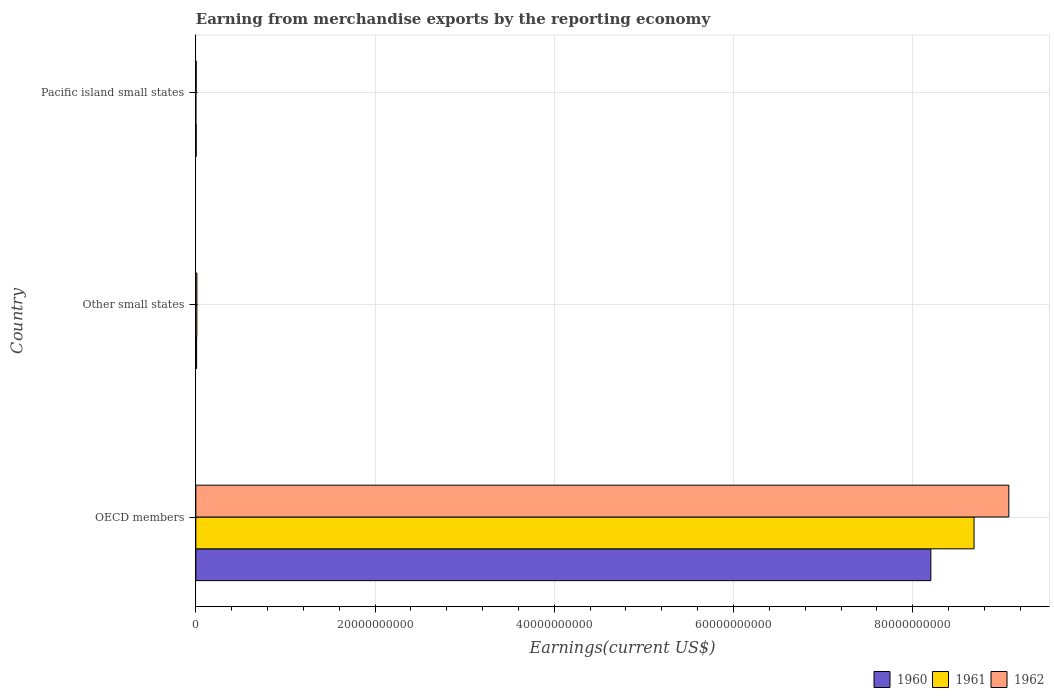How many groups of bars are there?
Keep it short and to the point. 3. Are the number of bars on each tick of the Y-axis equal?
Keep it short and to the point. Yes. How many bars are there on the 3rd tick from the top?
Your answer should be compact. 3. How many bars are there on the 1st tick from the bottom?
Ensure brevity in your answer.  3. What is the amount earned from merchandise exports in 1961 in Pacific island small states?
Your answer should be compact. 2.00e+05. Across all countries, what is the maximum amount earned from merchandise exports in 1960?
Offer a very short reply. 8.20e+1. In which country was the amount earned from merchandise exports in 1962 minimum?
Keep it short and to the point. Pacific island small states. What is the total amount earned from merchandise exports in 1961 in the graph?
Your answer should be very brief. 8.70e+1. What is the difference between the amount earned from merchandise exports in 1960 in OECD members and that in Other small states?
Ensure brevity in your answer.  8.19e+1. What is the difference between the amount earned from merchandise exports in 1960 in Pacific island small states and the amount earned from merchandise exports in 1961 in Other small states?
Offer a very short reply. -7.61e+07. What is the average amount earned from merchandise exports in 1962 per country?
Your answer should be very brief. 3.03e+1. What is the difference between the amount earned from merchandise exports in 1961 and amount earned from merchandise exports in 1960 in Pacific island small states?
Your response must be concise. -3.93e+07. In how many countries, is the amount earned from merchandise exports in 1960 greater than 72000000000 US$?
Offer a terse response. 1. What is the ratio of the amount earned from merchandise exports in 1962 in Other small states to that in Pacific island small states?
Provide a succinct answer. 2.99. What is the difference between the highest and the second highest amount earned from merchandise exports in 1960?
Provide a succinct answer. 8.19e+1. What is the difference between the highest and the lowest amount earned from merchandise exports in 1962?
Provide a short and direct response. 9.07e+1. Is it the case that in every country, the sum of the amount earned from merchandise exports in 1960 and amount earned from merchandise exports in 1961 is greater than the amount earned from merchandise exports in 1962?
Your answer should be very brief. No. How many bars are there?
Your response must be concise. 9. What is the difference between two consecutive major ticks on the X-axis?
Give a very brief answer. 2.00e+1. Where does the legend appear in the graph?
Your answer should be compact. Bottom right. What is the title of the graph?
Offer a terse response. Earning from merchandise exports by the reporting economy. What is the label or title of the X-axis?
Ensure brevity in your answer.  Earnings(current US$). What is the Earnings(current US$) in 1960 in OECD members?
Give a very brief answer. 8.20e+1. What is the Earnings(current US$) of 1961 in OECD members?
Keep it short and to the point. 8.68e+1. What is the Earnings(current US$) in 1962 in OECD members?
Provide a short and direct response. 9.07e+1. What is the Earnings(current US$) of 1960 in Other small states?
Provide a short and direct response. 8.66e+07. What is the Earnings(current US$) of 1961 in Other small states?
Ensure brevity in your answer.  1.16e+08. What is the Earnings(current US$) of 1962 in Other small states?
Your answer should be compact. 1.19e+08. What is the Earnings(current US$) of 1960 in Pacific island small states?
Give a very brief answer. 3.95e+07. What is the Earnings(current US$) in 1961 in Pacific island small states?
Provide a succinct answer. 2.00e+05. What is the Earnings(current US$) of 1962 in Pacific island small states?
Offer a terse response. 3.97e+07. Across all countries, what is the maximum Earnings(current US$) in 1960?
Offer a terse response. 8.20e+1. Across all countries, what is the maximum Earnings(current US$) in 1961?
Your answer should be very brief. 8.68e+1. Across all countries, what is the maximum Earnings(current US$) in 1962?
Offer a terse response. 9.07e+1. Across all countries, what is the minimum Earnings(current US$) of 1960?
Offer a terse response. 3.95e+07. Across all countries, what is the minimum Earnings(current US$) of 1962?
Provide a short and direct response. 3.97e+07. What is the total Earnings(current US$) in 1960 in the graph?
Provide a succinct answer. 8.22e+1. What is the total Earnings(current US$) in 1961 in the graph?
Your response must be concise. 8.70e+1. What is the total Earnings(current US$) of 1962 in the graph?
Offer a terse response. 9.09e+1. What is the difference between the Earnings(current US$) of 1960 in OECD members and that in Other small states?
Your response must be concise. 8.19e+1. What is the difference between the Earnings(current US$) in 1961 in OECD members and that in Other small states?
Your response must be concise. 8.67e+1. What is the difference between the Earnings(current US$) of 1962 in OECD members and that in Other small states?
Your response must be concise. 9.06e+1. What is the difference between the Earnings(current US$) of 1960 in OECD members and that in Pacific island small states?
Keep it short and to the point. 8.20e+1. What is the difference between the Earnings(current US$) in 1961 in OECD members and that in Pacific island small states?
Your response must be concise. 8.68e+1. What is the difference between the Earnings(current US$) in 1962 in OECD members and that in Pacific island small states?
Your answer should be compact. 9.07e+1. What is the difference between the Earnings(current US$) of 1960 in Other small states and that in Pacific island small states?
Give a very brief answer. 4.71e+07. What is the difference between the Earnings(current US$) in 1961 in Other small states and that in Pacific island small states?
Your response must be concise. 1.15e+08. What is the difference between the Earnings(current US$) of 1962 in Other small states and that in Pacific island small states?
Keep it short and to the point. 7.91e+07. What is the difference between the Earnings(current US$) in 1960 in OECD members and the Earnings(current US$) in 1961 in Other small states?
Offer a very short reply. 8.19e+1. What is the difference between the Earnings(current US$) in 1960 in OECD members and the Earnings(current US$) in 1962 in Other small states?
Provide a short and direct response. 8.19e+1. What is the difference between the Earnings(current US$) of 1961 in OECD members and the Earnings(current US$) of 1962 in Other small states?
Provide a succinct answer. 8.67e+1. What is the difference between the Earnings(current US$) of 1960 in OECD members and the Earnings(current US$) of 1961 in Pacific island small states?
Give a very brief answer. 8.20e+1. What is the difference between the Earnings(current US$) of 1960 in OECD members and the Earnings(current US$) of 1962 in Pacific island small states?
Your answer should be compact. 8.20e+1. What is the difference between the Earnings(current US$) of 1961 in OECD members and the Earnings(current US$) of 1962 in Pacific island small states?
Your answer should be compact. 8.68e+1. What is the difference between the Earnings(current US$) in 1960 in Other small states and the Earnings(current US$) in 1961 in Pacific island small states?
Your answer should be very brief. 8.64e+07. What is the difference between the Earnings(current US$) of 1960 in Other small states and the Earnings(current US$) of 1962 in Pacific island small states?
Ensure brevity in your answer.  4.69e+07. What is the difference between the Earnings(current US$) of 1961 in Other small states and the Earnings(current US$) of 1962 in Pacific island small states?
Make the answer very short. 7.59e+07. What is the average Earnings(current US$) of 1960 per country?
Ensure brevity in your answer.  2.74e+1. What is the average Earnings(current US$) of 1961 per country?
Make the answer very short. 2.90e+1. What is the average Earnings(current US$) in 1962 per country?
Your answer should be compact. 3.03e+1. What is the difference between the Earnings(current US$) in 1960 and Earnings(current US$) in 1961 in OECD members?
Give a very brief answer. -4.82e+09. What is the difference between the Earnings(current US$) of 1960 and Earnings(current US$) of 1962 in OECD members?
Make the answer very short. -8.70e+09. What is the difference between the Earnings(current US$) of 1961 and Earnings(current US$) of 1962 in OECD members?
Ensure brevity in your answer.  -3.88e+09. What is the difference between the Earnings(current US$) in 1960 and Earnings(current US$) in 1961 in Other small states?
Ensure brevity in your answer.  -2.90e+07. What is the difference between the Earnings(current US$) of 1960 and Earnings(current US$) of 1962 in Other small states?
Ensure brevity in your answer.  -3.22e+07. What is the difference between the Earnings(current US$) in 1961 and Earnings(current US$) in 1962 in Other small states?
Make the answer very short. -3.20e+06. What is the difference between the Earnings(current US$) in 1960 and Earnings(current US$) in 1961 in Pacific island small states?
Provide a succinct answer. 3.93e+07. What is the difference between the Earnings(current US$) in 1960 and Earnings(current US$) in 1962 in Pacific island small states?
Ensure brevity in your answer.  -2.00e+05. What is the difference between the Earnings(current US$) of 1961 and Earnings(current US$) of 1962 in Pacific island small states?
Ensure brevity in your answer.  -3.95e+07. What is the ratio of the Earnings(current US$) in 1960 in OECD members to that in Other small states?
Keep it short and to the point. 947.22. What is the ratio of the Earnings(current US$) of 1961 in OECD members to that in Other small states?
Provide a succinct answer. 751.29. What is the ratio of the Earnings(current US$) in 1962 in OECD members to that in Other small states?
Provide a succinct answer. 763.73. What is the ratio of the Earnings(current US$) of 1960 in OECD members to that in Pacific island small states?
Provide a short and direct response. 2076.69. What is the ratio of the Earnings(current US$) in 1961 in OECD members to that in Pacific island small states?
Provide a short and direct response. 4.34e+05. What is the ratio of the Earnings(current US$) in 1962 in OECD members to that in Pacific island small states?
Ensure brevity in your answer.  2285.43. What is the ratio of the Earnings(current US$) of 1960 in Other small states to that in Pacific island small states?
Make the answer very short. 2.19. What is the ratio of the Earnings(current US$) in 1961 in Other small states to that in Pacific island small states?
Provide a succinct answer. 578. What is the ratio of the Earnings(current US$) in 1962 in Other small states to that in Pacific island small states?
Give a very brief answer. 2.99. What is the difference between the highest and the second highest Earnings(current US$) in 1960?
Give a very brief answer. 8.19e+1. What is the difference between the highest and the second highest Earnings(current US$) of 1961?
Give a very brief answer. 8.67e+1. What is the difference between the highest and the second highest Earnings(current US$) in 1962?
Offer a very short reply. 9.06e+1. What is the difference between the highest and the lowest Earnings(current US$) in 1960?
Your answer should be very brief. 8.20e+1. What is the difference between the highest and the lowest Earnings(current US$) in 1961?
Make the answer very short. 8.68e+1. What is the difference between the highest and the lowest Earnings(current US$) of 1962?
Your answer should be compact. 9.07e+1. 